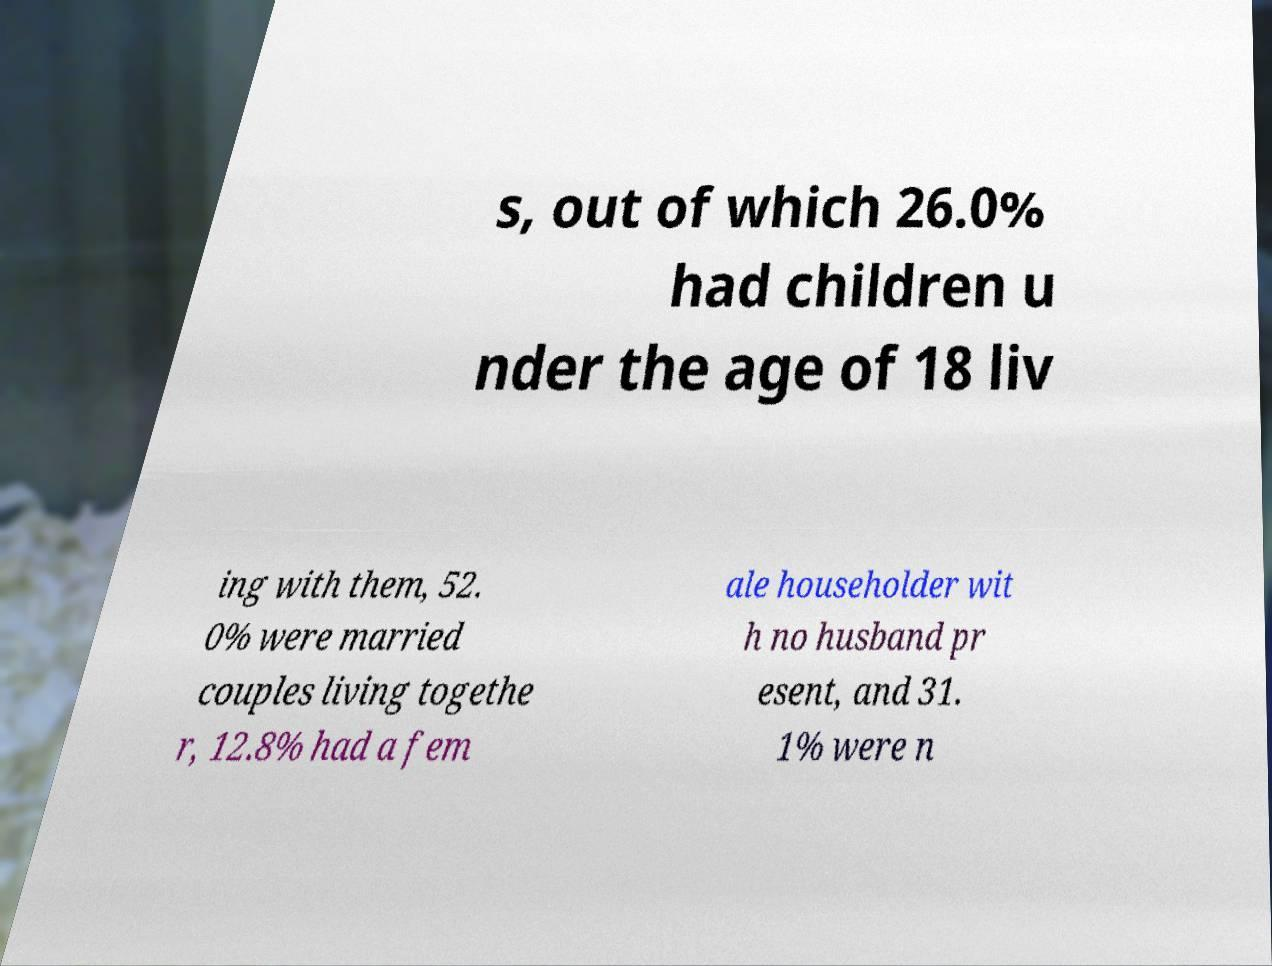Please read and relay the text visible in this image. What does it say? s, out of which 26.0% had children u nder the age of 18 liv ing with them, 52. 0% were married couples living togethe r, 12.8% had a fem ale householder wit h no husband pr esent, and 31. 1% were n 